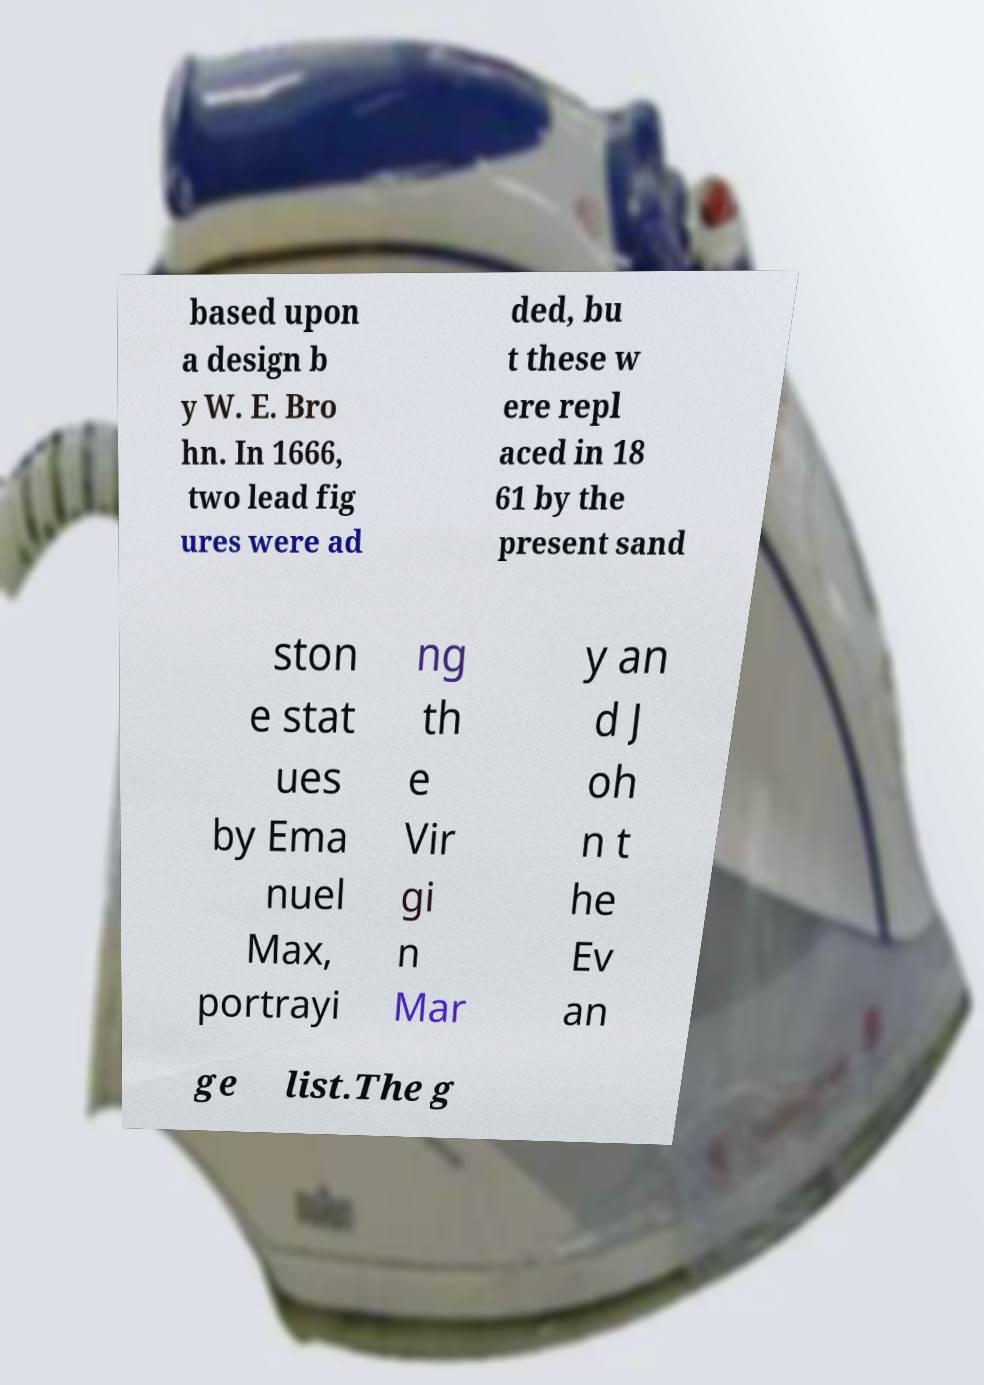Can you accurately transcribe the text from the provided image for me? based upon a design b y W. E. Bro hn. In 1666, two lead fig ures were ad ded, bu t these w ere repl aced in 18 61 by the present sand ston e stat ues by Ema nuel Max, portrayi ng th e Vir gi n Mar y an d J oh n t he Ev an ge list.The g 